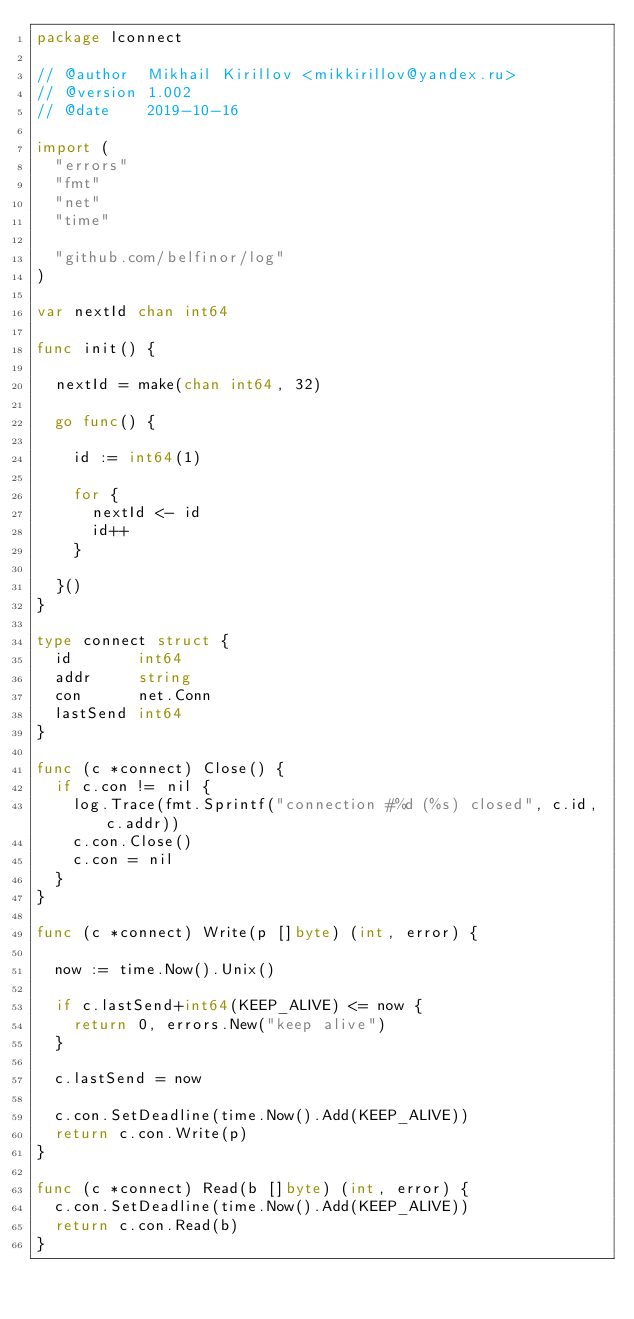<code> <loc_0><loc_0><loc_500><loc_500><_Go_>package lconnect

// @author  Mikhail Kirillov <mikkirillov@yandex.ru>
// @version 1.002
// @date    2019-10-16

import (
	"errors"
	"fmt"
	"net"
	"time"

	"github.com/belfinor/log"
)

var nextId chan int64

func init() {

	nextId = make(chan int64, 32)

	go func() {

		id := int64(1)

		for {
			nextId <- id
			id++
		}

	}()
}

type connect struct {
	id       int64
	addr     string
	con      net.Conn
	lastSend int64
}

func (c *connect) Close() {
	if c.con != nil {
		log.Trace(fmt.Sprintf("connection #%d (%s) closed", c.id, c.addr))
		c.con.Close()
		c.con = nil
	}
}

func (c *connect) Write(p []byte) (int, error) {

	now := time.Now().Unix()

	if c.lastSend+int64(KEEP_ALIVE) <= now {
		return 0, errors.New("keep alive")
	}

	c.lastSend = now

	c.con.SetDeadline(time.Now().Add(KEEP_ALIVE))
	return c.con.Write(p)
}

func (c *connect) Read(b []byte) (int, error) {
	c.con.SetDeadline(time.Now().Add(KEEP_ALIVE))
	return c.con.Read(b)
}
</code> 